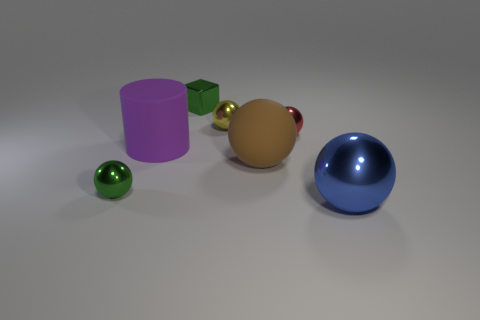Are there fewer purple rubber things than purple matte cubes?
Ensure brevity in your answer.  No. Does the large brown thing have the same shape as the green thing that is in front of the large cylinder?
Make the answer very short. Yes. There is a small thing that is both on the left side of the tiny yellow object and behind the big matte cylinder; what shape is it?
Provide a short and direct response. Cube. Is the number of large objects behind the red metallic sphere the same as the number of tiny metal objects that are in front of the block?
Offer a terse response. No. Do the small object that is to the right of the brown sphere and the brown object have the same shape?
Your answer should be compact. Yes. How many green objects are big matte balls or blocks?
Offer a very short reply. 1. There is a tiny green thing that is the same shape as the small red thing; what is it made of?
Offer a very short reply. Metal. There is a green shiny object that is to the left of the green metallic block; what shape is it?
Your response must be concise. Sphere. Are there any tiny yellow objects that have the same material as the blue ball?
Provide a short and direct response. Yes. Does the yellow sphere have the same size as the purple thing?
Ensure brevity in your answer.  No. 